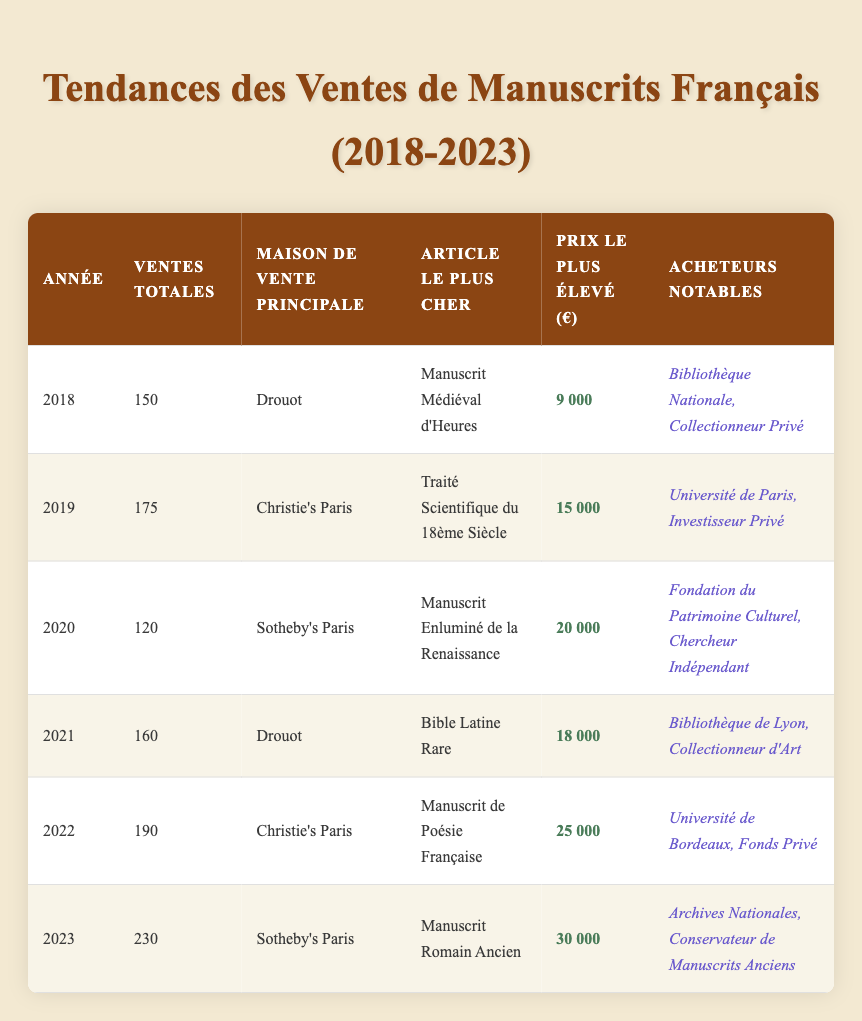What was the total number of sales in 2022? In the table, when looking at the row for the year 2022, the column for total sales indicates that the total number of sales was 190.
Answer: 190 Which auction house had the highest sale price item in 2023? By examining the 2023 row, it is noted that Sotheby's Paris was the auction house associated with the highest sale price item, which was the Ancient Roman Manuscript for 30,000 euros.
Answer: Sotheby's Paris What is the average high sale price from 2018 to 2023? To find the average high sale price, first sum the high sale prices: 9000 + 15000 + 20000 + 18000 + 25000 + 30000 = 117000. Next, divide by the total number of years, which is 6. Therefore, the average is 117000 / 6 = 19500.
Answer: 19500 Did the total sales increase every year from 2018 to 2023? Looking at the total sales for each year, it can be observed: 150 (2018), 175 (2019), 120 (2020), 160 (2021), 190 (2022), and 230 (2023). The total sales decreased from 2019 to 2020, indicating that it did not increase every year.
Answer: No Which notable buyer purchased the highest sale item in 2022? Referring to the 2022 row, the highest sale item was the Manuscript of French Poetry, and the notable buyers listed were the University of Bordeaux and a Private Fund. Both are notable, but the institution is University of Bordeaux.
Answer: University of Bordeaux What was the highest price increase between two consecutive years? By reviewing the high sale prices for consecutive years: 2018 (9000), 2019 (15000), 2020 (20000), 2021 (18000), 2022 (25000), and 2023 (30000), we calculate the differences: 6000 (2018 to 2019), 5000 (2019 to 2020), -2000 (2020 to 2021), 7000 (2021 to 2022), and 5000 (2022 to 2023). The largest increase is 7000 between 2021 and 2022.
Answer: 7000 How many notable buyers were involved in the purchases in 2020? The 2020 row lists two notable buyers: the Cultural Heritage Foundation and an Independent Scholar. Therefore, the total number of notable buyers in 2020 is 2.
Answer: 2 Was the year 2021 better in sales than 2020? Examining the total sales for 2021 (160) compared to 2020 (120), it's clear that 2021 had more sales than 2020.
Answer: Yes Which year had the highest number of sales, and how many were there? From the total sales data: 2018 (150), 2019 (175), 2020 (120), 2021 (160), 2022 (190), and 2023 (230), the highest number of sales occurred in 2023 with 230 sales.
Answer: 2023, 230 